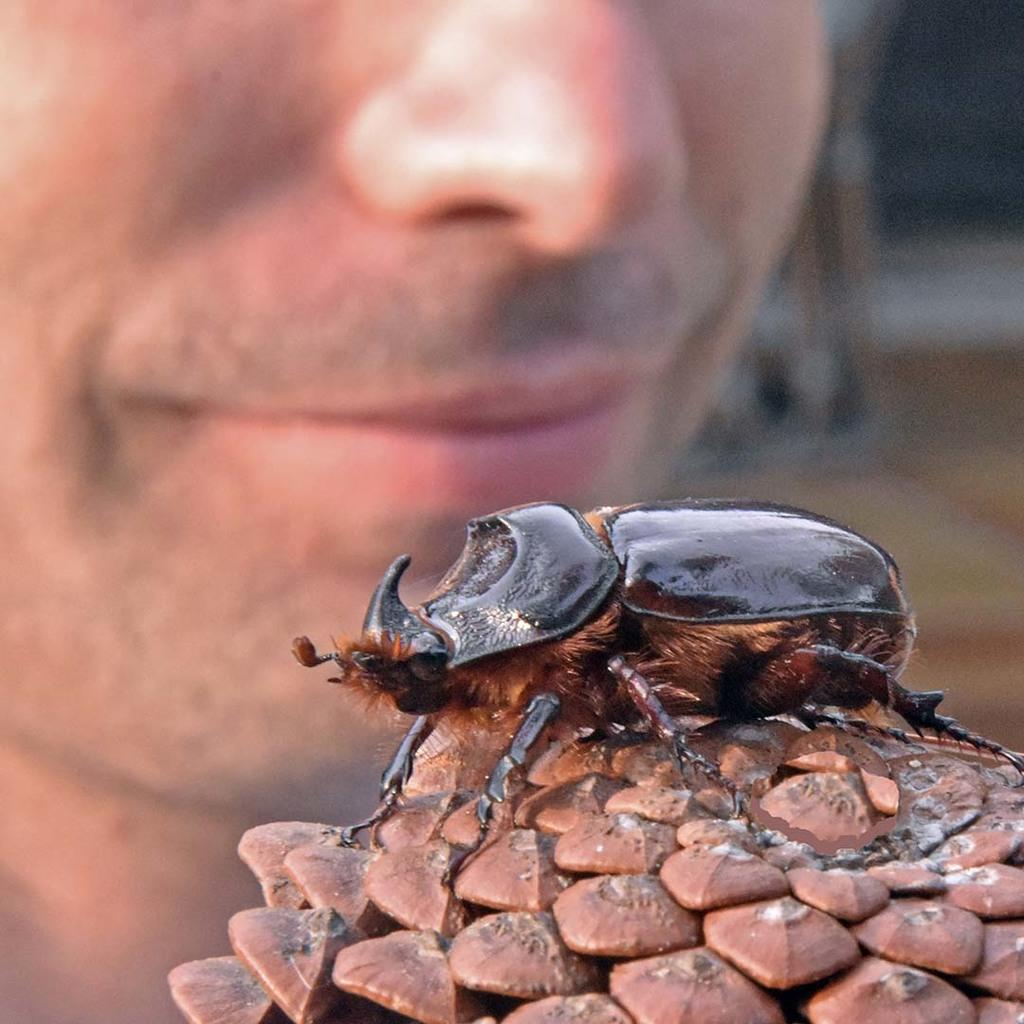What type of creature is present in the image? There is an insect in the image. Can you describe the colors of the insect? The insect has brown and black colors. What is the insect resting on in the image? The insect is on a brown-colored object. Is there any indication of a person in the image? Yes, there is a person's face visible in the background of the image. What type of jam is the insect spreading on the person's face in the image? There is no jam present in the image, nor is the insect spreading anything on the person's face. 